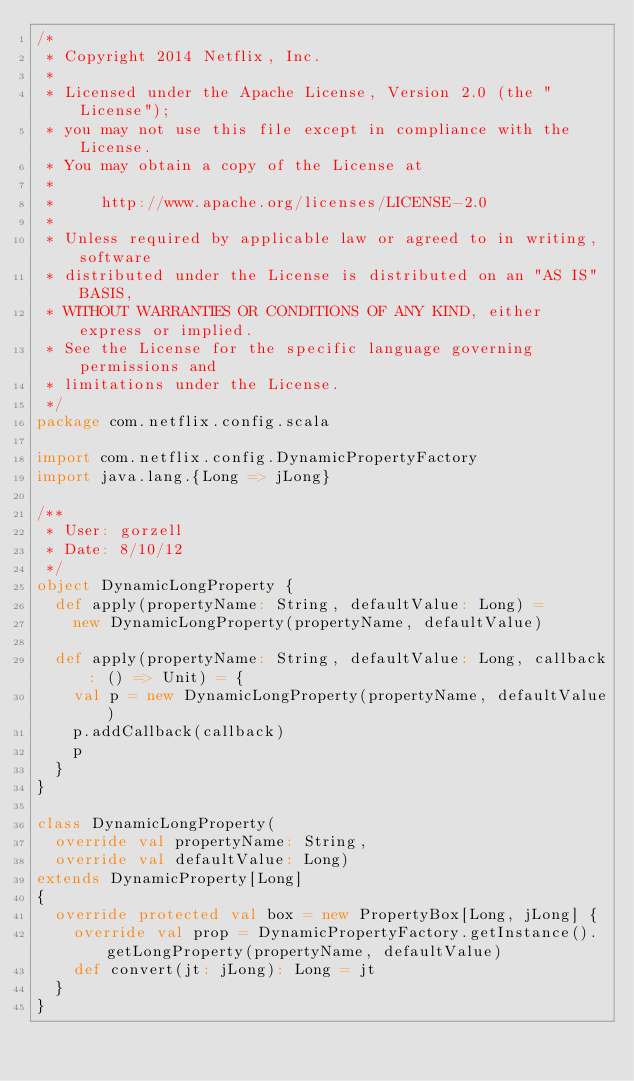<code> <loc_0><loc_0><loc_500><loc_500><_Scala_>/*
 * Copyright 2014 Netflix, Inc.
 *
 * Licensed under the Apache License, Version 2.0 (the "License");
 * you may not use this file except in compliance with the License.
 * You may obtain a copy of the License at
 *
 *     http://www.apache.org/licenses/LICENSE-2.0
 *
 * Unless required by applicable law or agreed to in writing, software
 * distributed under the License is distributed on an "AS IS" BASIS,
 * WITHOUT WARRANTIES OR CONDITIONS OF ANY KIND, either express or implied.
 * See the License for the specific language governing permissions and
 * limitations under the License.
 */
package com.netflix.config.scala

import com.netflix.config.DynamicPropertyFactory
import java.lang.{Long => jLong}

/**
 * User: gorzell
 * Date: 8/10/12
 */
object DynamicLongProperty {
  def apply(propertyName: String, defaultValue: Long) =
    new DynamicLongProperty(propertyName, defaultValue)

  def apply(propertyName: String, defaultValue: Long, callback: () => Unit) = {
    val p = new DynamicLongProperty(propertyName, defaultValue)
    p.addCallback(callback)
    p
  }
}

class DynamicLongProperty(
  override val propertyName: String,
  override val defaultValue: Long)
extends DynamicProperty[Long]
{
  override protected val box = new PropertyBox[Long, jLong] {
    override val prop = DynamicPropertyFactory.getInstance().getLongProperty(propertyName, defaultValue)
    def convert(jt: jLong): Long = jt
  }
}
</code> 